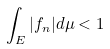<formula> <loc_0><loc_0><loc_500><loc_500>\int _ { E } | f _ { n } | d \mu < 1</formula> 